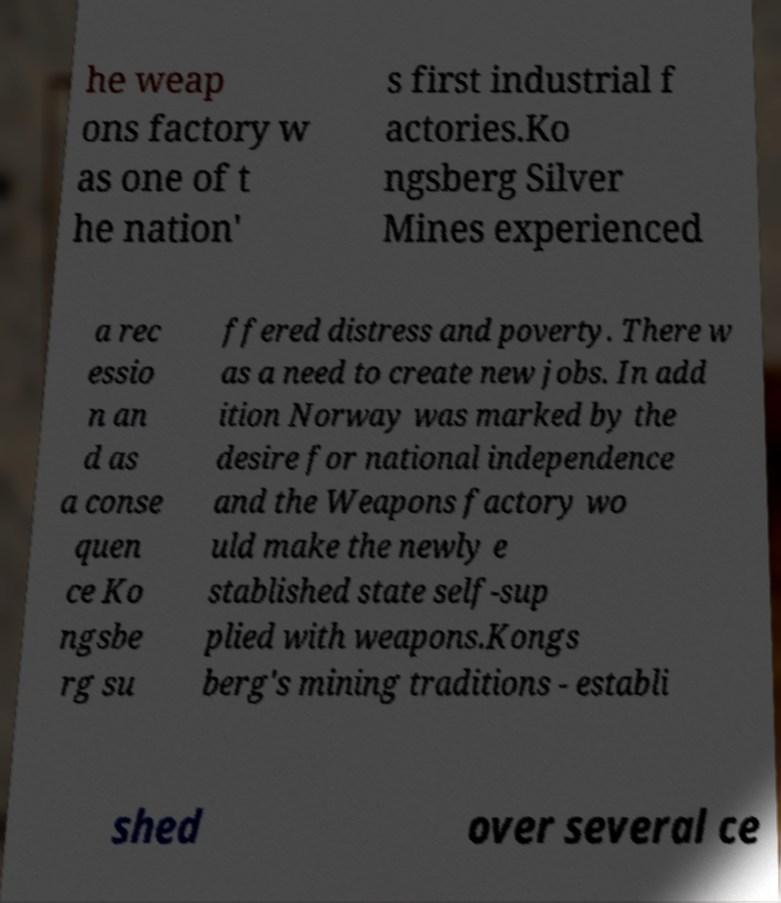Can you read and provide the text displayed in the image?This photo seems to have some interesting text. Can you extract and type it out for me? he weap ons factory w as one of t he nation' s first industrial f actories.Ko ngsberg Silver Mines experienced a rec essio n an d as a conse quen ce Ko ngsbe rg su ffered distress and poverty. There w as a need to create new jobs. In add ition Norway was marked by the desire for national independence and the Weapons factory wo uld make the newly e stablished state self-sup plied with weapons.Kongs berg's mining traditions - establi shed over several ce 